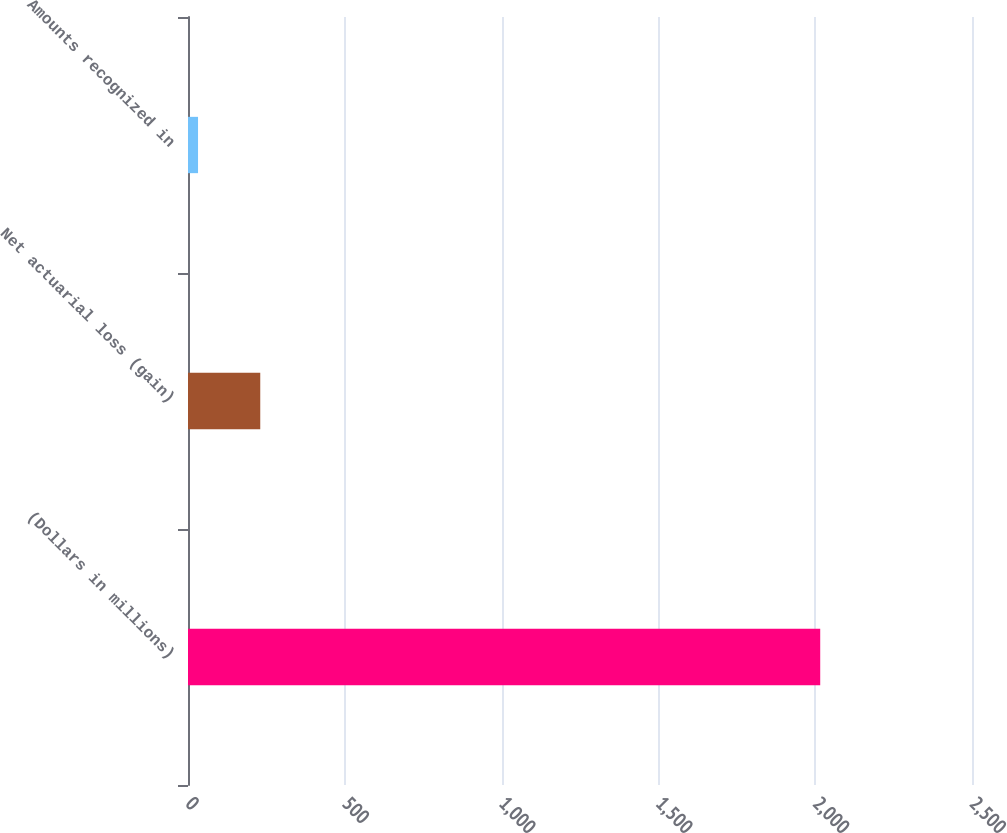Convert chart. <chart><loc_0><loc_0><loc_500><loc_500><bar_chart><fcel>(Dollars in millions)<fcel>Net actuarial loss (gain)<fcel>Amounts recognized in<nl><fcel>2016<fcel>230.4<fcel>32<nl></chart> 